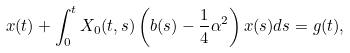<formula> <loc_0><loc_0><loc_500><loc_500>x ( t ) + \int _ { 0 } ^ { t } X _ { 0 } ( t , s ) \left ( b ( s ) - \frac { 1 } { 4 } { \alpha } ^ { 2 } \right ) x ( s ) d s = g ( t ) ,</formula> 